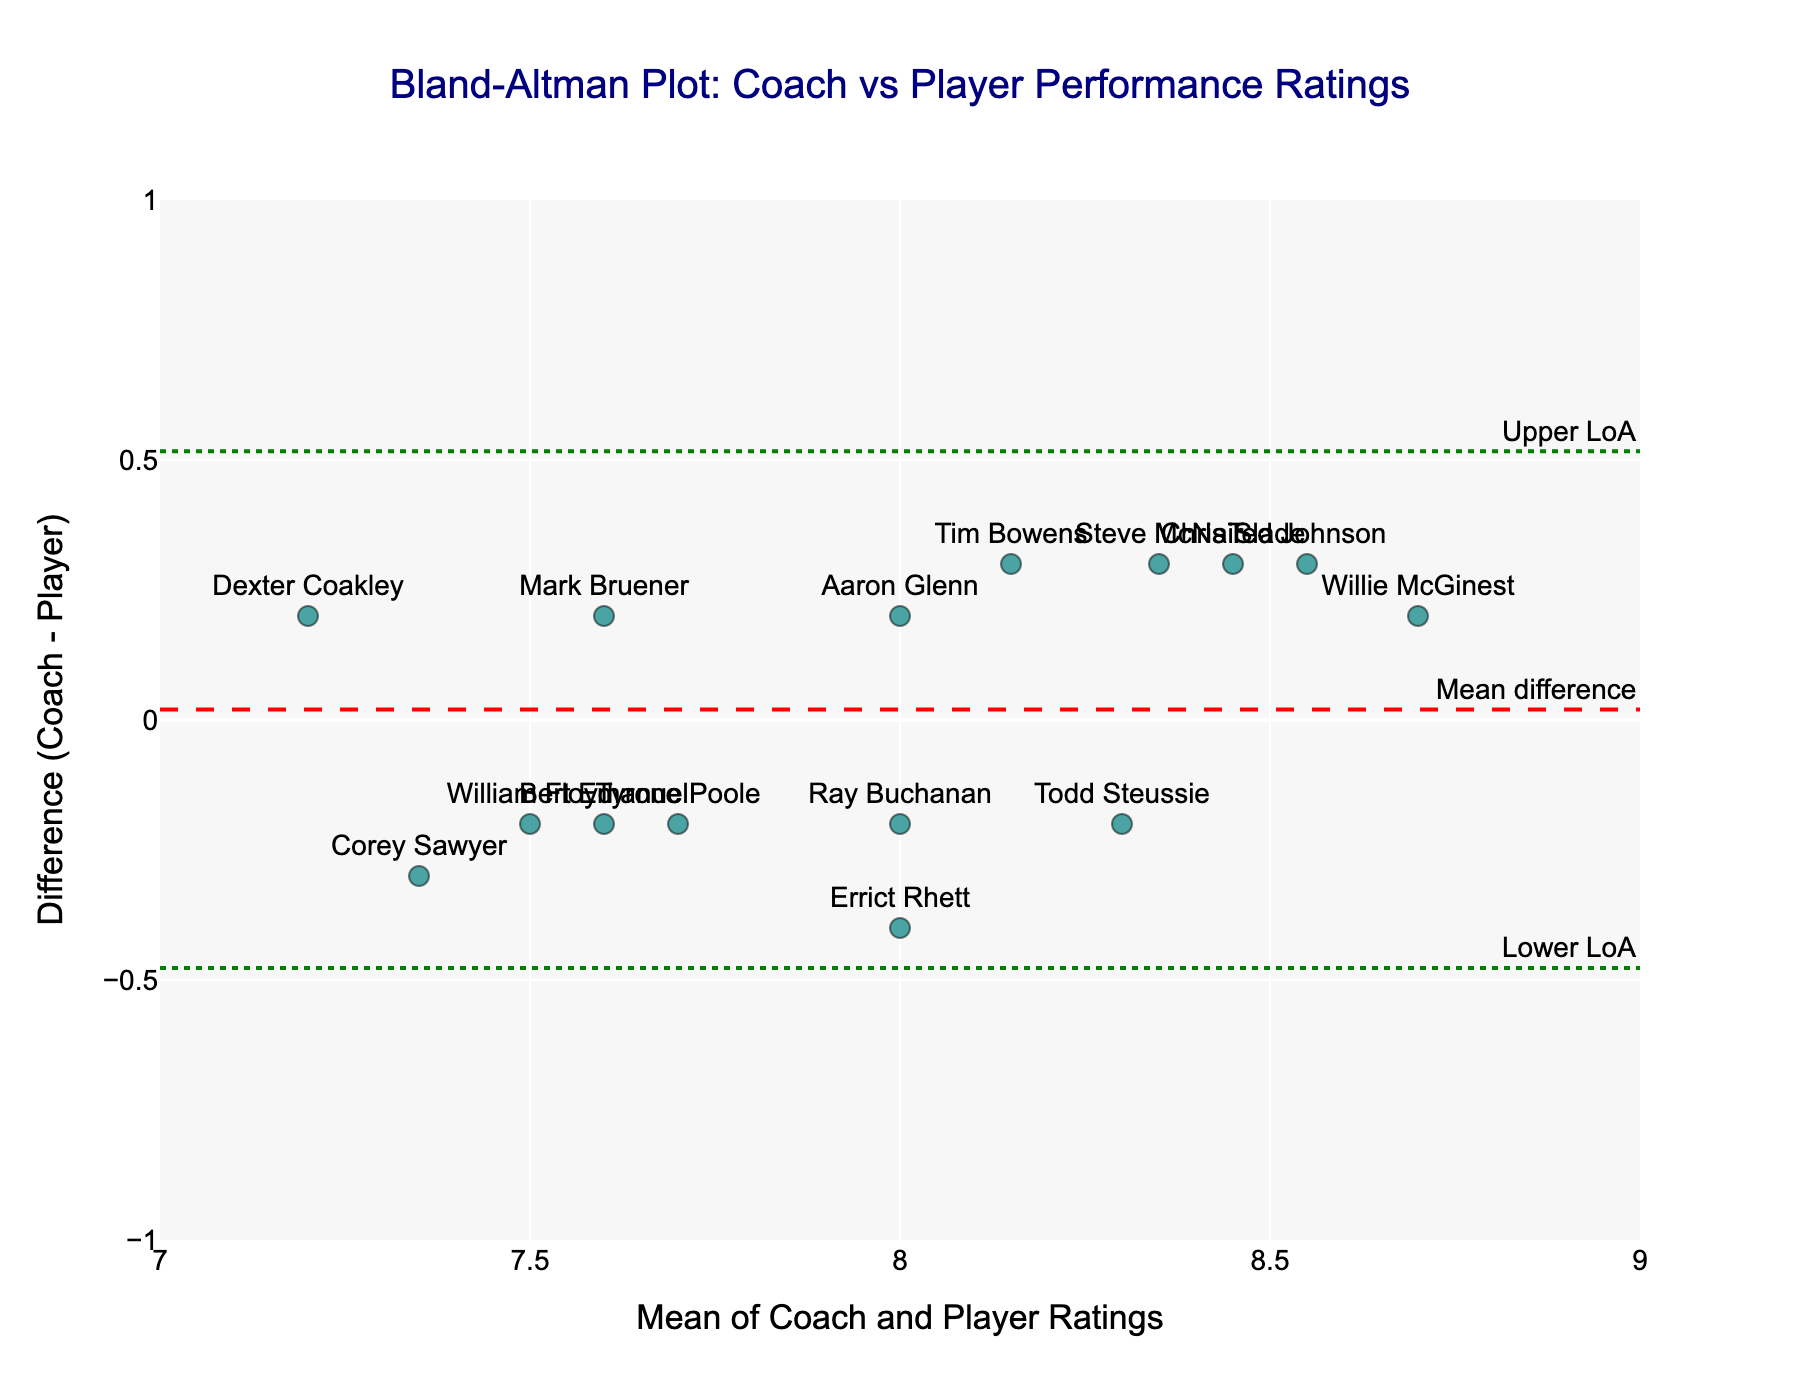what is the title of the plot? The title of the plot is usually located at the top of the figure and provides a summary of what the figure represents. In this case, it says "Bland-Altman Plot: Coach vs Player Performance Ratings."
Answer: Bland-Altman Plot: Coach vs Player Performance Ratings What is the range of the x-axis? The x-axis range is indicated by the starting and ending values at the ends of the axis. It spans from 7 to 9 in this figure.
Answer: 7 to 9 What is the mean difference line value in this plot? The mean difference line value is typically shown as a horizontal line labeled in plots. In this figure, it is labeled "Mean difference" and appears at around 0.
Answer: 0 Which player has the highest mean rating? To identify the player with the highest mean rating, look at the plotted points along the x-axis to find the point furthest to the right. The highest mean rating is represented by the player Willie McGinest.
Answer: Willie McGinest What is the upper limit of agreement (Upper LoA) value? The upper limit of agreement (Upper LoA) is usually indicated by a horizontal dashed line labeled in the plot. In this figure, it is labeled "Upper LoA" and is around 0.584.
Answer: 0.584 How many players have ratings lying outside the limits of agreement? To determine this, count the plotted points that fall above the upper limit or below the lower limit of agreement lines. In this figure, there are no points outside these limits.
Answer: 0 Which player has the largest difference between coach and player ratings? To find the largest difference, look for the point furthest from the mean difference (y=0) on the y-axis. Dexter Coakley, at the lowest point, has the largest negative difference.
Answer: Dexter Coakley What player is at the mean difference line? A player's point on the mean difference line (y=0) indicates their coach and self-ratings are the same. Todd Steussie has a point that lies exactly on this line.
Answer: Todd Steussie Are most of the coach ratings higher or lower than the self-ratings? Identify the general trend by observing the majority of points; if they lie above or below the zero line. Most points are centered around the line or slightly above it, indicating coach ratings are slightly higher or similar to the self-ratings.
Answer: Slightly higher or similar 